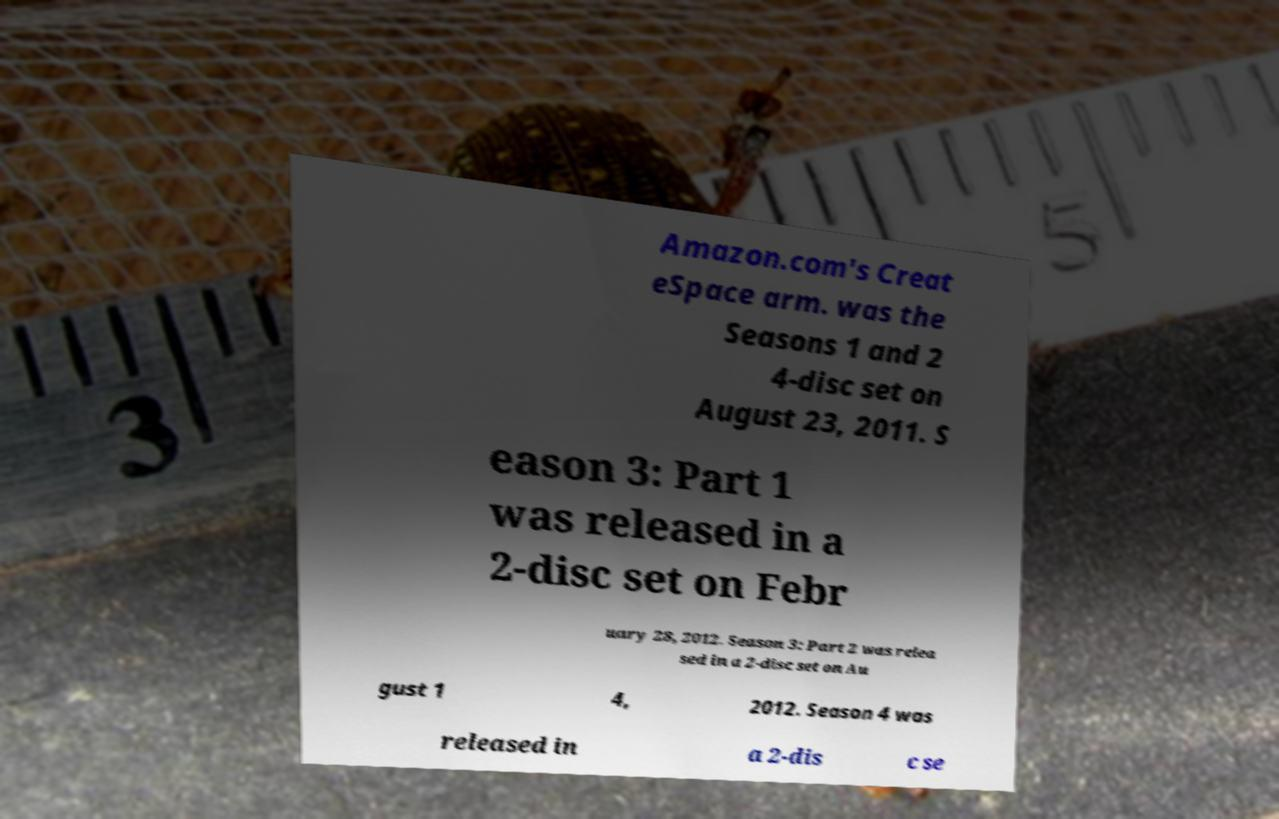Could you extract and type out the text from this image? Amazon.com's Creat eSpace arm. was the Seasons 1 and 2 4-disc set on August 23, 2011. S eason 3: Part 1 was released in a 2-disc set on Febr uary 28, 2012. Season 3: Part 2 was relea sed in a 2-disc set on Au gust 1 4, 2012. Season 4 was released in a 2-dis c se 